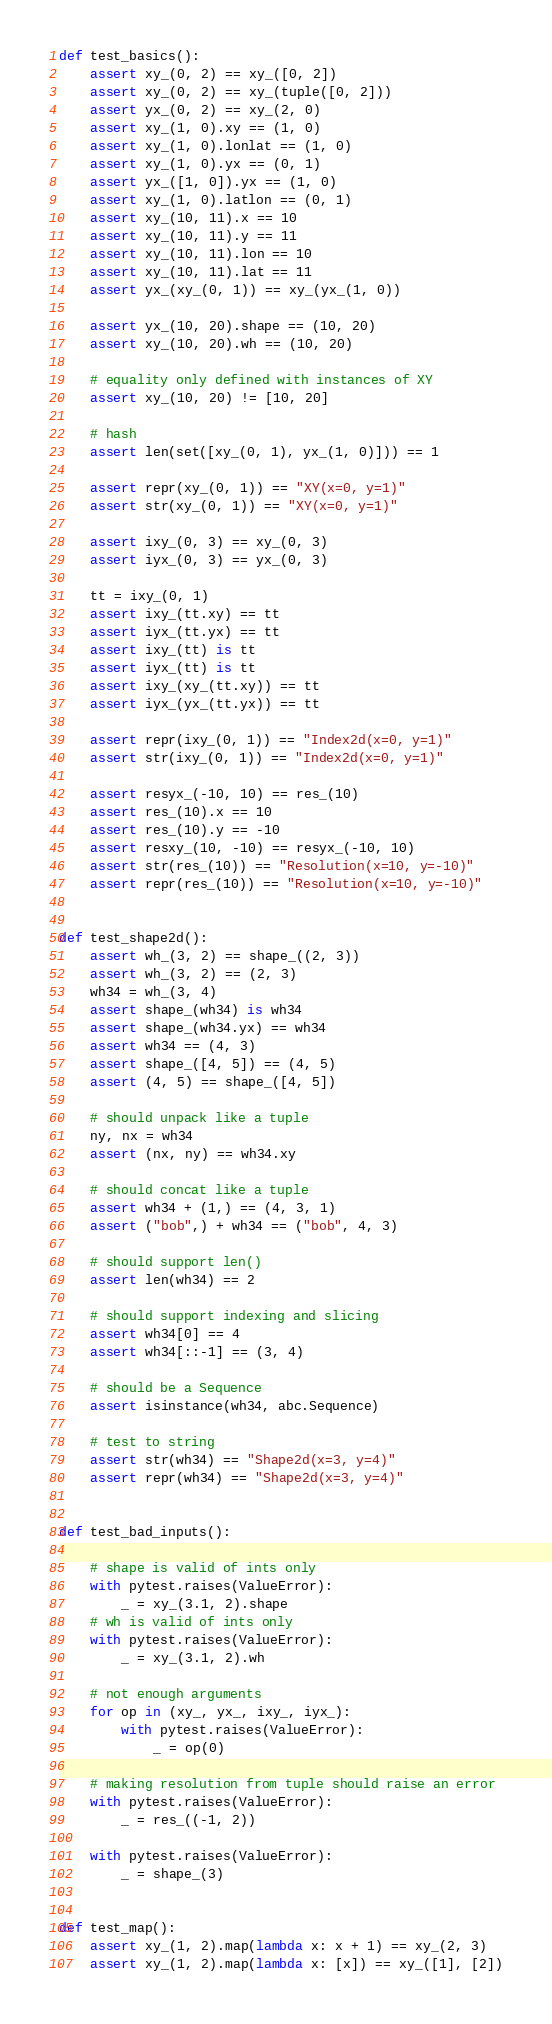<code> <loc_0><loc_0><loc_500><loc_500><_Python_>

def test_basics():
    assert xy_(0, 2) == xy_([0, 2])
    assert xy_(0, 2) == xy_(tuple([0, 2]))
    assert yx_(0, 2) == xy_(2, 0)
    assert xy_(1, 0).xy == (1, 0)
    assert xy_(1, 0).lonlat == (1, 0)
    assert xy_(1, 0).yx == (0, 1)
    assert yx_([1, 0]).yx == (1, 0)
    assert xy_(1, 0).latlon == (0, 1)
    assert xy_(10, 11).x == 10
    assert xy_(10, 11).y == 11
    assert xy_(10, 11).lon == 10
    assert xy_(10, 11).lat == 11
    assert yx_(xy_(0, 1)) == xy_(yx_(1, 0))

    assert yx_(10, 20).shape == (10, 20)
    assert xy_(10, 20).wh == (10, 20)

    # equality only defined with instances of XY
    assert xy_(10, 20) != [10, 20]

    # hash
    assert len(set([xy_(0, 1), yx_(1, 0)])) == 1

    assert repr(xy_(0, 1)) == "XY(x=0, y=1)"
    assert str(xy_(0, 1)) == "XY(x=0, y=1)"

    assert ixy_(0, 3) == xy_(0, 3)
    assert iyx_(0, 3) == yx_(0, 3)

    tt = ixy_(0, 1)
    assert ixy_(tt.xy) == tt
    assert iyx_(tt.yx) == tt
    assert ixy_(tt) is tt
    assert iyx_(tt) is tt
    assert ixy_(xy_(tt.xy)) == tt
    assert iyx_(yx_(tt.yx)) == tt

    assert repr(ixy_(0, 1)) == "Index2d(x=0, y=1)"
    assert str(ixy_(0, 1)) == "Index2d(x=0, y=1)"

    assert resyx_(-10, 10) == res_(10)
    assert res_(10).x == 10
    assert res_(10).y == -10
    assert resxy_(10, -10) == resyx_(-10, 10)
    assert str(res_(10)) == "Resolution(x=10, y=-10)"
    assert repr(res_(10)) == "Resolution(x=10, y=-10)"


def test_shape2d():
    assert wh_(3, 2) == shape_((2, 3))
    assert wh_(3, 2) == (2, 3)
    wh34 = wh_(3, 4)
    assert shape_(wh34) is wh34
    assert shape_(wh34.yx) == wh34
    assert wh34 == (4, 3)
    assert shape_([4, 5]) == (4, 5)
    assert (4, 5) == shape_([4, 5])

    # should unpack like a tuple
    ny, nx = wh34
    assert (nx, ny) == wh34.xy

    # should concat like a tuple
    assert wh34 + (1,) == (4, 3, 1)
    assert ("bob",) + wh34 == ("bob", 4, 3)

    # should support len()
    assert len(wh34) == 2

    # should support indexing and slicing
    assert wh34[0] == 4
    assert wh34[::-1] == (3, 4)

    # should be a Sequence
    assert isinstance(wh34, abc.Sequence)

    # test to string
    assert str(wh34) == "Shape2d(x=3, y=4)"
    assert repr(wh34) == "Shape2d(x=3, y=4)"


def test_bad_inputs():

    # shape is valid of ints only
    with pytest.raises(ValueError):
        _ = xy_(3.1, 2).shape
    # wh is valid of ints only
    with pytest.raises(ValueError):
        _ = xy_(3.1, 2).wh

    # not enough arguments
    for op in (xy_, yx_, ixy_, iyx_):
        with pytest.raises(ValueError):
            _ = op(0)

    # making resolution from tuple should raise an error
    with pytest.raises(ValueError):
        _ = res_((-1, 2))

    with pytest.raises(ValueError):
        _ = shape_(3)


def test_map():
    assert xy_(1, 2).map(lambda x: x + 1) == xy_(2, 3)
    assert xy_(1, 2).map(lambda x: [x]) == xy_([1], [2])
</code> 